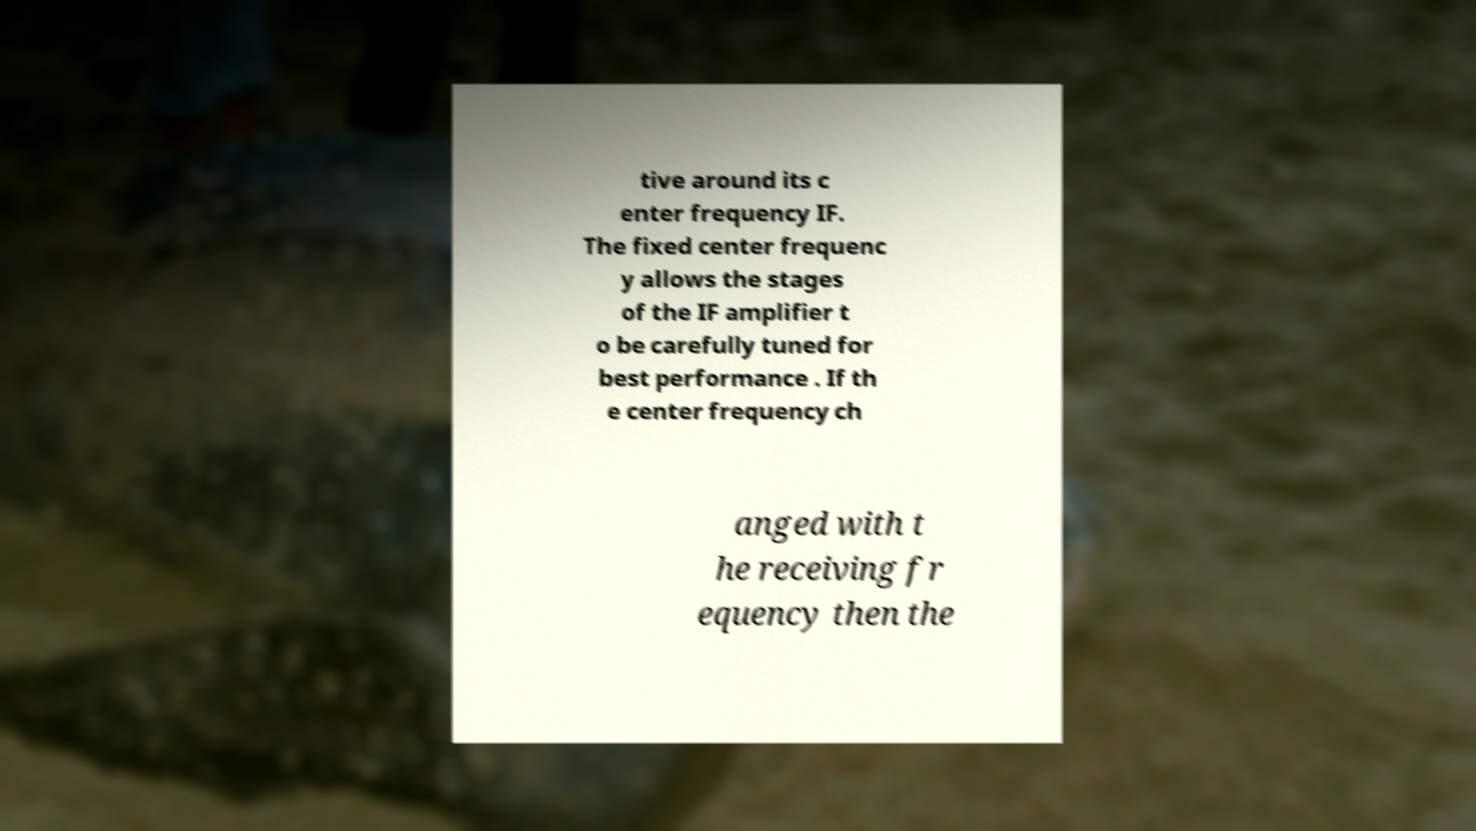Can you accurately transcribe the text from the provided image for me? tive around its c enter frequency IF. The fixed center frequenc y allows the stages of the IF amplifier t o be carefully tuned for best performance . If th e center frequency ch anged with t he receiving fr equency then the 